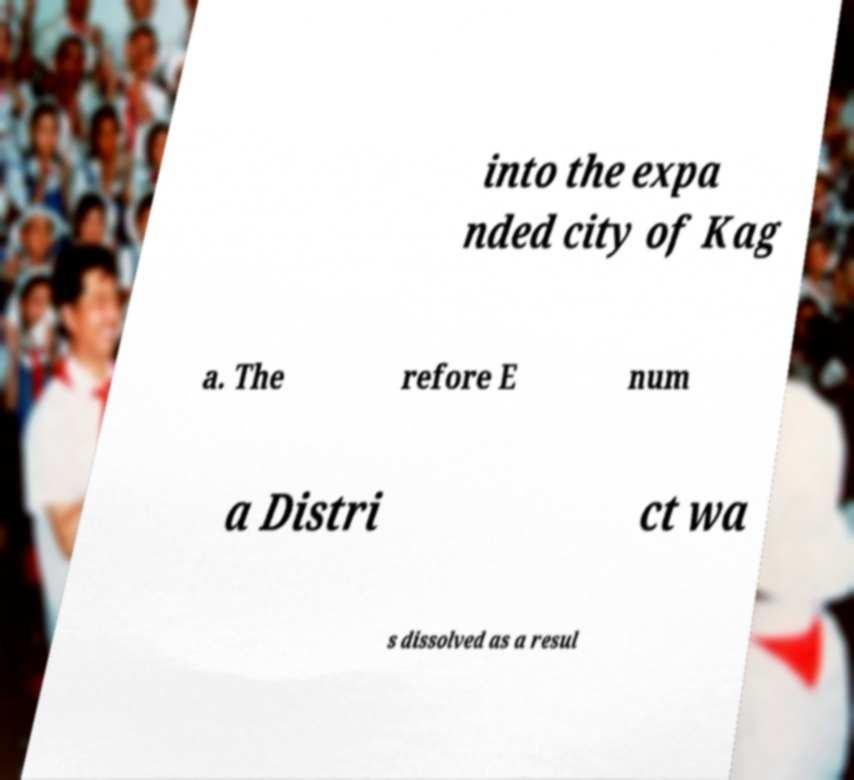Can you read and provide the text displayed in the image?This photo seems to have some interesting text. Can you extract and type it out for me? into the expa nded city of Kag a. The refore E num a Distri ct wa s dissolved as a resul 